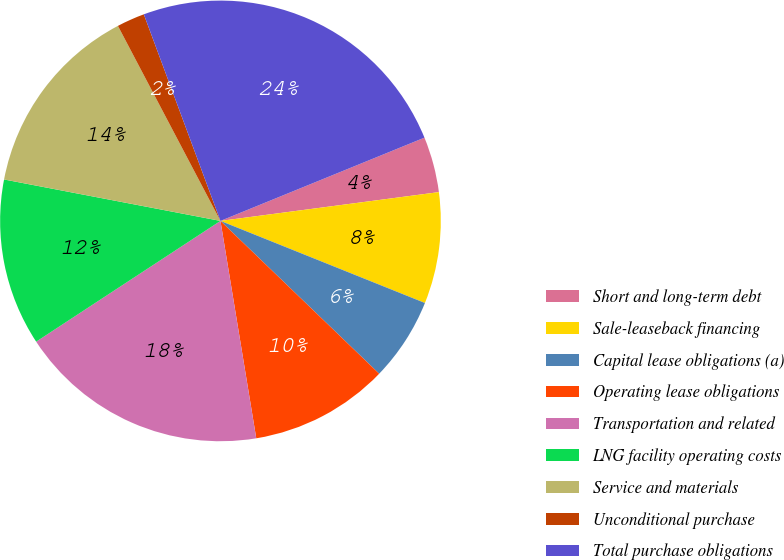<chart> <loc_0><loc_0><loc_500><loc_500><pie_chart><fcel>Short and long-term debt<fcel>Sale-leaseback financing<fcel>Capital lease obligations (a)<fcel>Operating lease obligations<fcel>Transportation and related<fcel>LNG facility operating costs<fcel>Service and materials<fcel>Unconditional purchase<fcel>Total purchase obligations<nl><fcel>4.08%<fcel>8.16%<fcel>6.12%<fcel>10.2%<fcel>18.36%<fcel>12.24%<fcel>14.28%<fcel>2.05%<fcel>24.48%<nl></chart> 